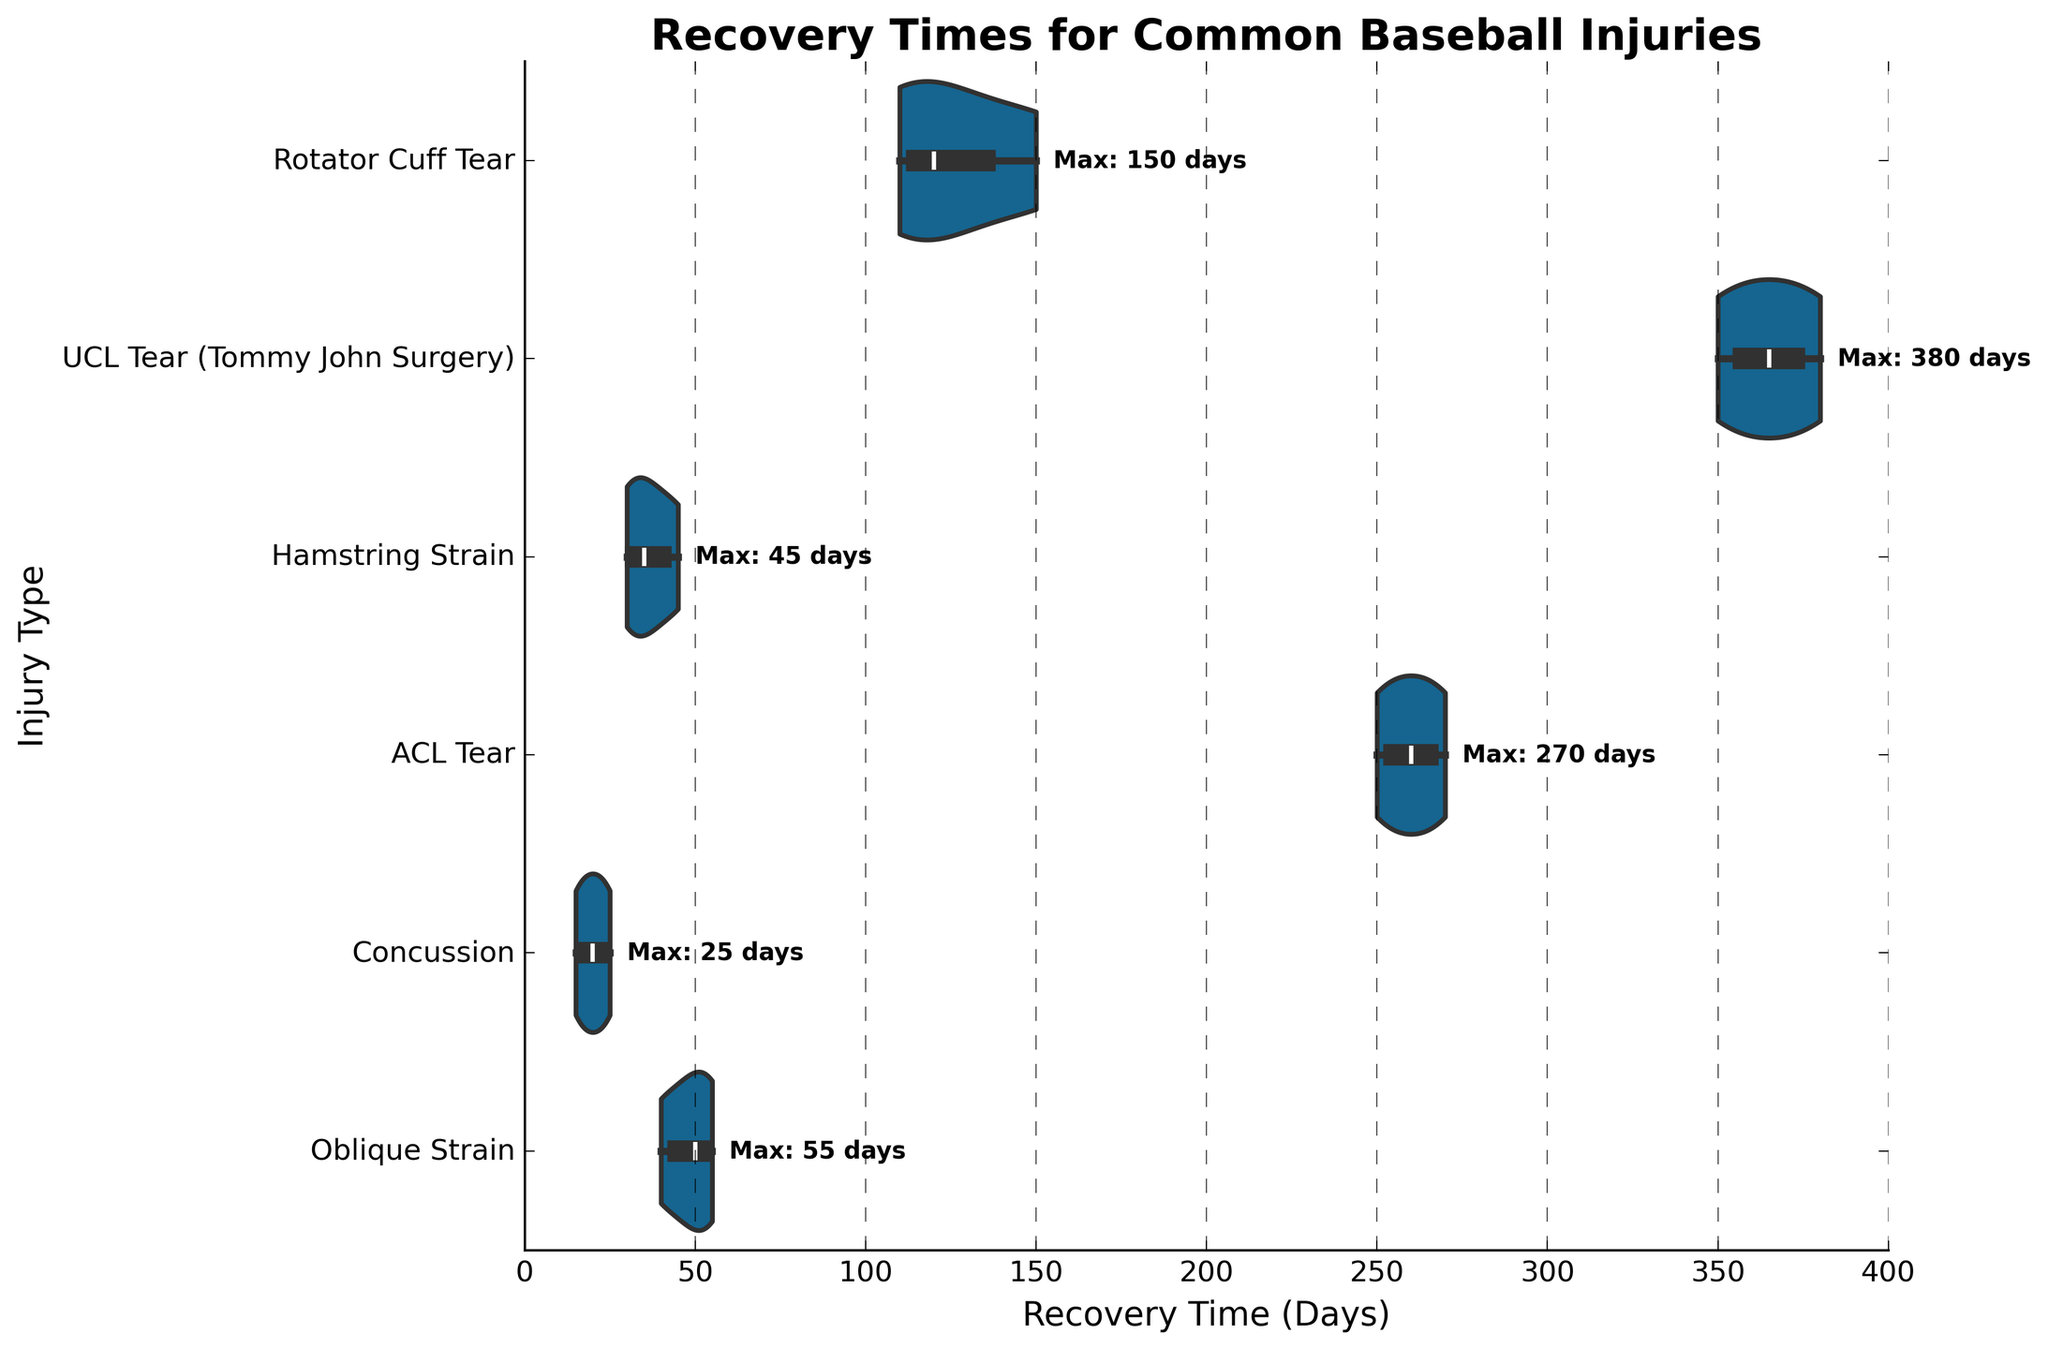What is the title of the figure? The title is located at the top of the figure and is meant to provide a summary of what the chart represents
Answer: Recovery Times for Common Baseball Injuries Which injury has the longest recovery time? By observing the horizontal extent of the violins, you can see which extends furthest to the right, indicating the longest recovery time
Answer: UCL Tear (Tommy John Surgery) What is the maximum recovery time for an ACL Tear? Look at the text annotations near the ACL Tear category in the y-axis, it marks "Max: 270 days"
Answer: 270 days On average, how long does it take to recover from a Hamstring Strain? To get the average, note that Hamstring Strain recovery times fall around the middle of their violin; they peak around 30, 35, and 45 days
Answer: Approximately 37 days Compare the range of recovery times for Rotator Cuff Tear and Concussion injuries. Which has a wider range? Rotator Cuff Tear violin spans from 110 to 150 days. Concussion violin spans from 15 to 25 days. Thus, the range for Rotator Cuff Tear is wider (40 days), compared to the concussion's range (10 days)
Answer: Rotator Cuff Tear How does the median recovery time for an Oblique Strain compare to that of a Hamstring Strain? Within each violin, the central white line represents the median. The median recovery time for Oblique Strain looks slightly above 45 days whereas for Hamstring Strain, it's around 35 days
Answer: Oblique Strain is greater What can we infer about the variability of recovery times for UCL Tear compared to Concussion? The width of the violin plots indicates variability. The UCL Tear violin is much wider across its range compared to the Concussion violin, indicating higher variability in recovery times
Answer: UCL Tear has higher variability Which injuries have a peak recovery time of 20 days or less? Refer to the location of peaks within the violins. Concussion has a peak within the 15-20 days range
Answer: Concussion What injury has the closest maximum recovery time to that of Rotator Cuff Tear? Observe the text annotations for maximal recovery times. Rotator Cuff Tear's maximum is 150 days, closest similar is Oblique Strain with a peak max of 55 days but not very close. ACL Tear has 250 days which is also far off
Answer: None close to 150 days 